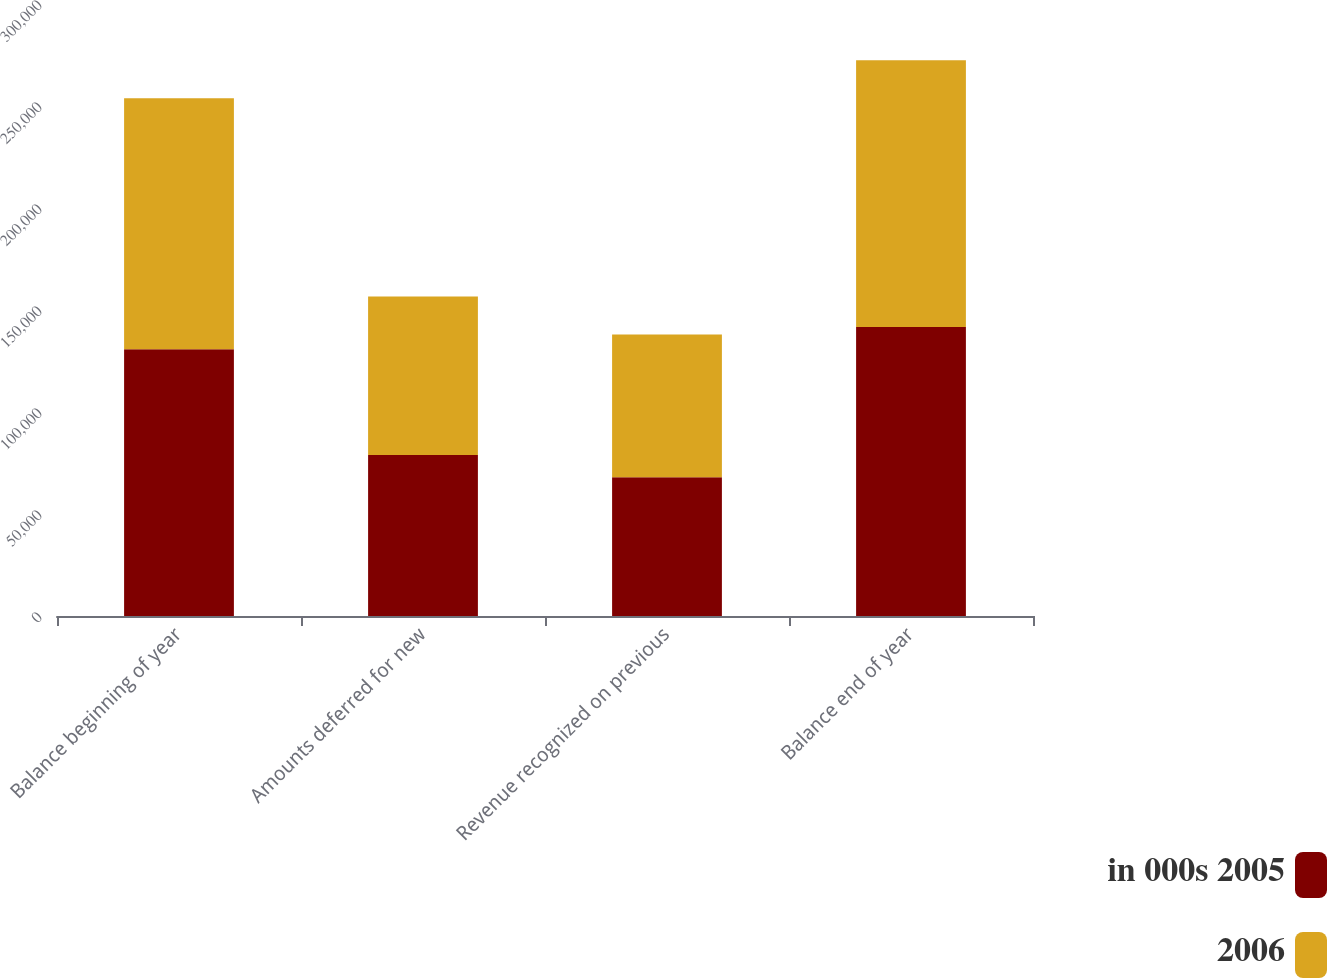Convert chart. <chart><loc_0><loc_0><loc_500><loc_500><stacked_bar_chart><ecel><fcel>Balance beginning of year<fcel>Amounts deferred for new<fcel>Revenue recognized on previous<fcel>Balance end of year<nl><fcel>in 000s 2005<fcel>130762<fcel>78900<fcel>67978<fcel>141684<nl><fcel>2006<fcel>123048<fcel>77756<fcel>70042<fcel>130762<nl></chart> 